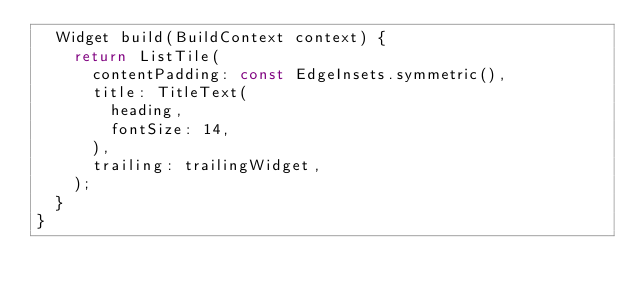Convert code to text. <code><loc_0><loc_0><loc_500><loc_500><_Dart_>  Widget build(BuildContext context) {
    return ListTile(
      contentPadding: const EdgeInsets.symmetric(),
      title: TitleText(
        heading,
        fontSize: 14,
      ),
      trailing: trailingWidget,
    );
  }
}
</code> 